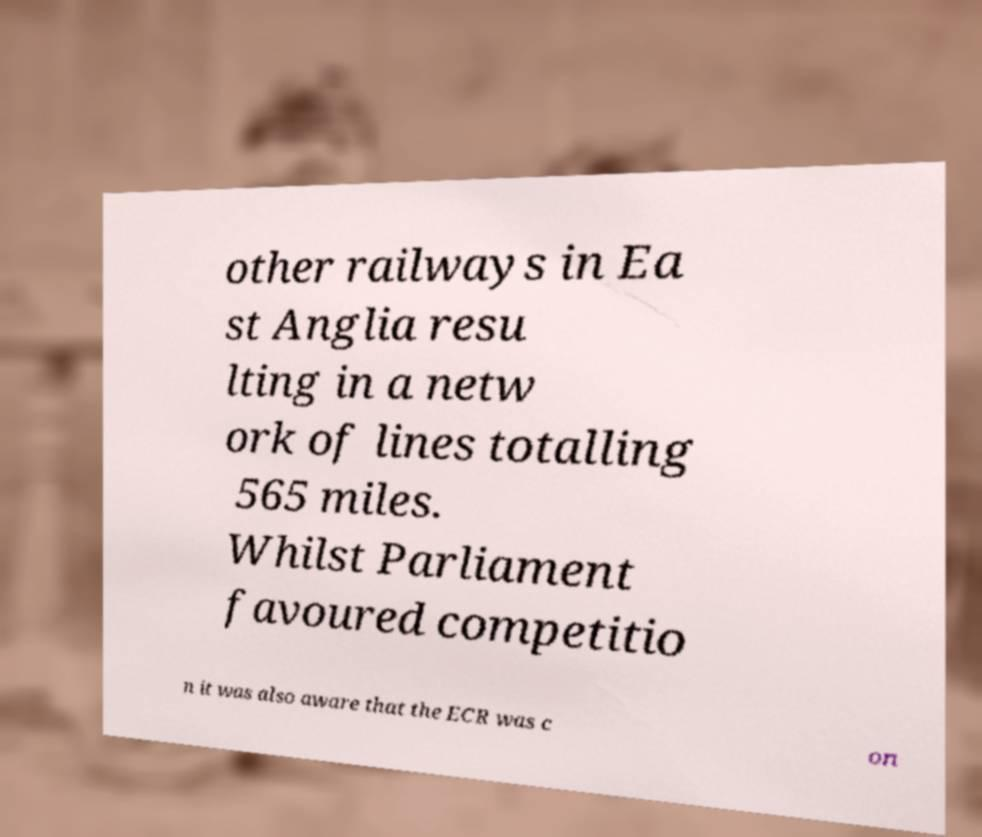I need the written content from this picture converted into text. Can you do that? other railways in Ea st Anglia resu lting in a netw ork of lines totalling 565 miles. Whilst Parliament favoured competitio n it was also aware that the ECR was c on 